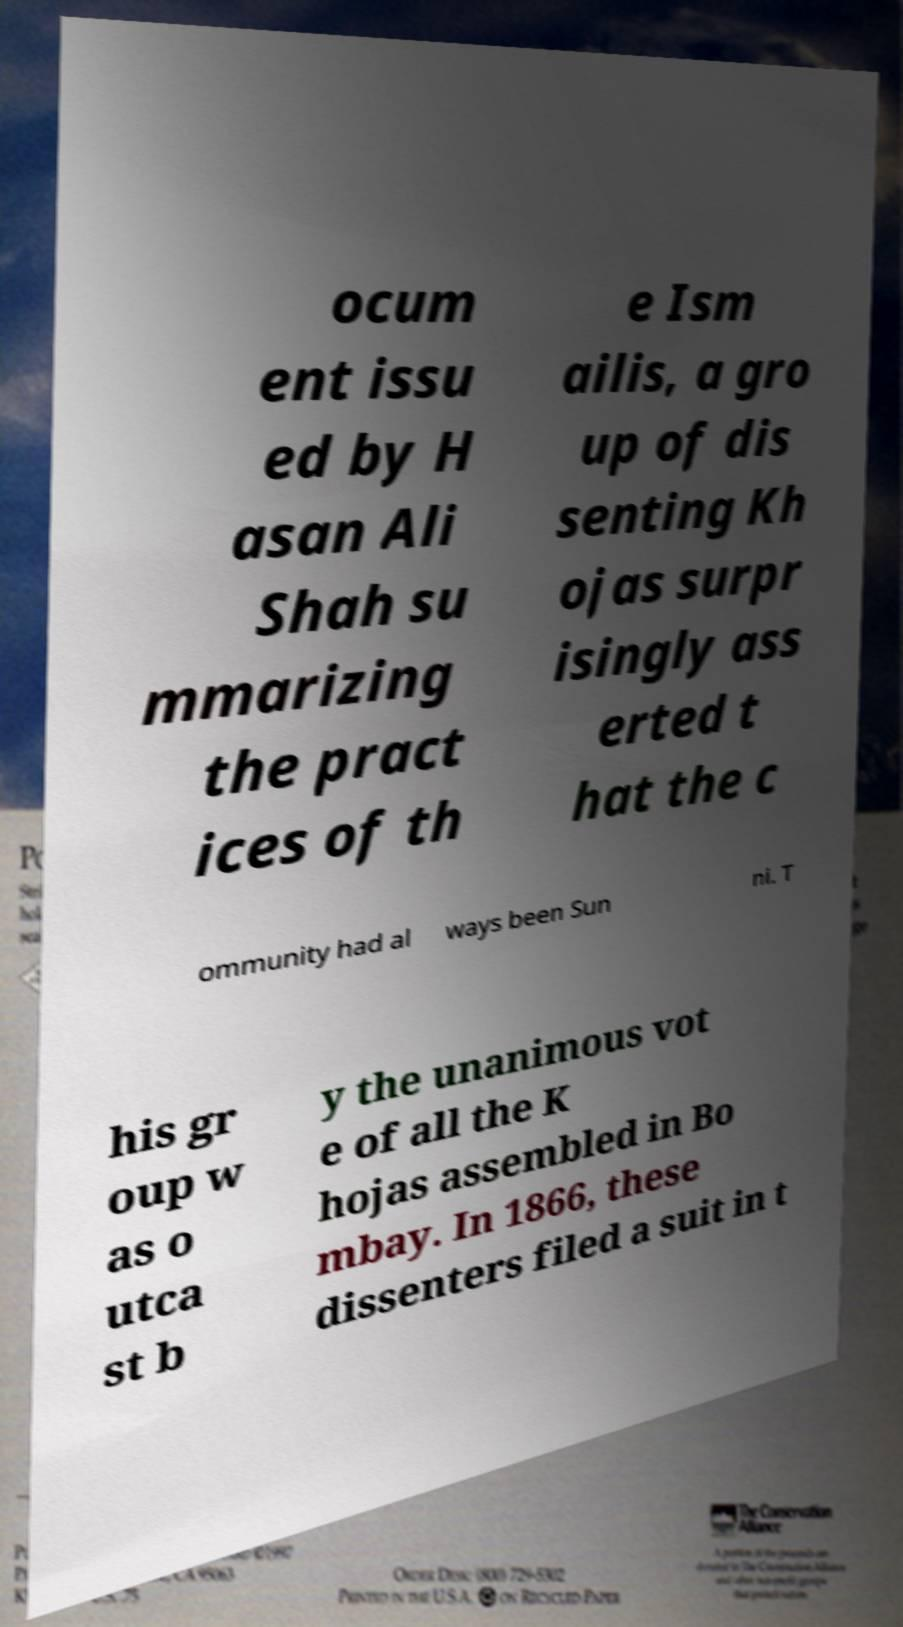Please read and relay the text visible in this image. What does it say? ocum ent issu ed by H asan Ali Shah su mmarizing the pract ices of th e Ism ailis, a gro up of dis senting Kh ojas surpr isingly ass erted t hat the c ommunity had al ways been Sun ni. T his gr oup w as o utca st b y the unanimous vot e of all the K hojas assembled in Bo mbay. In 1866, these dissenters filed a suit in t 